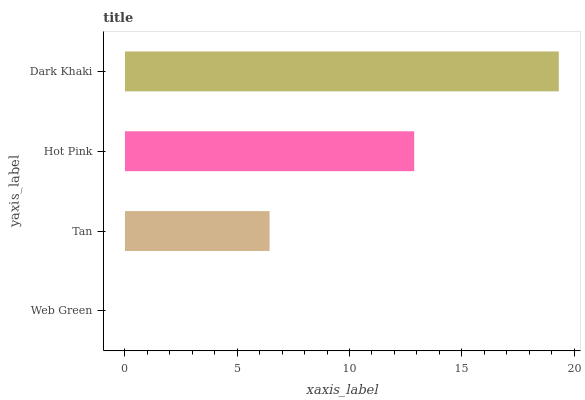Is Web Green the minimum?
Answer yes or no. Yes. Is Dark Khaki the maximum?
Answer yes or no. Yes. Is Tan the minimum?
Answer yes or no. No. Is Tan the maximum?
Answer yes or no. No. Is Tan greater than Web Green?
Answer yes or no. Yes. Is Web Green less than Tan?
Answer yes or no. Yes. Is Web Green greater than Tan?
Answer yes or no. No. Is Tan less than Web Green?
Answer yes or no. No. Is Hot Pink the high median?
Answer yes or no. Yes. Is Tan the low median?
Answer yes or no. Yes. Is Dark Khaki the high median?
Answer yes or no. No. Is Web Green the low median?
Answer yes or no. No. 